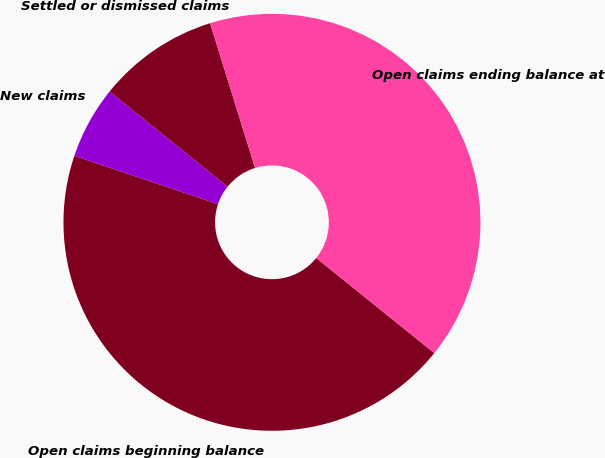Convert chart to OTSL. <chart><loc_0><loc_0><loc_500><loc_500><pie_chart><fcel>Open claims beginning balance<fcel>New claims<fcel>Settled or dismissed claims<fcel>Open claims ending balance at<nl><fcel>44.37%<fcel>5.63%<fcel>9.41%<fcel>40.59%<nl></chart> 